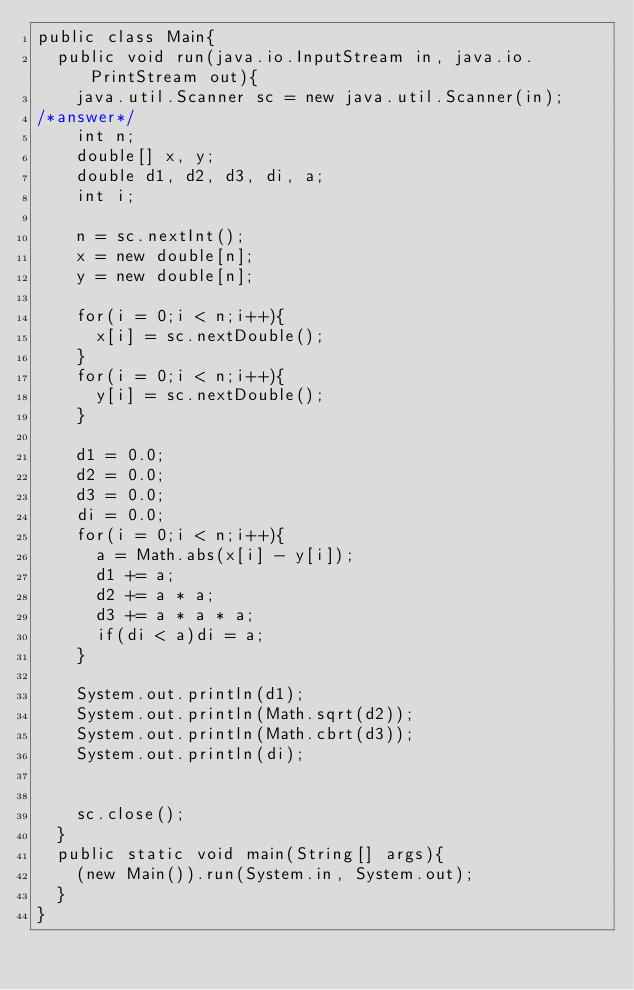<code> <loc_0><loc_0><loc_500><loc_500><_Java_>public class Main{
  public void run(java.io.InputStream in, java.io.PrintStream out){
    java.util.Scanner sc = new java.util.Scanner(in);
/*answer*/
    int n;
    double[] x, y;
    double d1, d2, d3, di, a;
    int i;

    n = sc.nextInt();
    x = new double[n];
    y = new double[n];

    for(i = 0;i < n;i++){
      x[i] = sc.nextDouble();
    }
    for(i = 0;i < n;i++){
      y[i] = sc.nextDouble();
    }

    d1 = 0.0;
    d2 = 0.0;
    d3 = 0.0;
    di = 0.0;
    for(i = 0;i < n;i++){
      a = Math.abs(x[i] - y[i]);
      d1 += a;
      d2 += a * a;
      d3 += a * a * a;
      if(di < a)di = a;
    }

    System.out.println(d1);
    System.out.println(Math.sqrt(d2));
    System.out.println(Math.cbrt(d3));
    System.out.println(di);


    sc.close();
  }
  public static void main(String[] args){
    (new Main()).run(System.in, System.out);
  }
}
</code> 